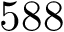<formula> <loc_0><loc_0><loc_500><loc_500>5 8 8</formula> 